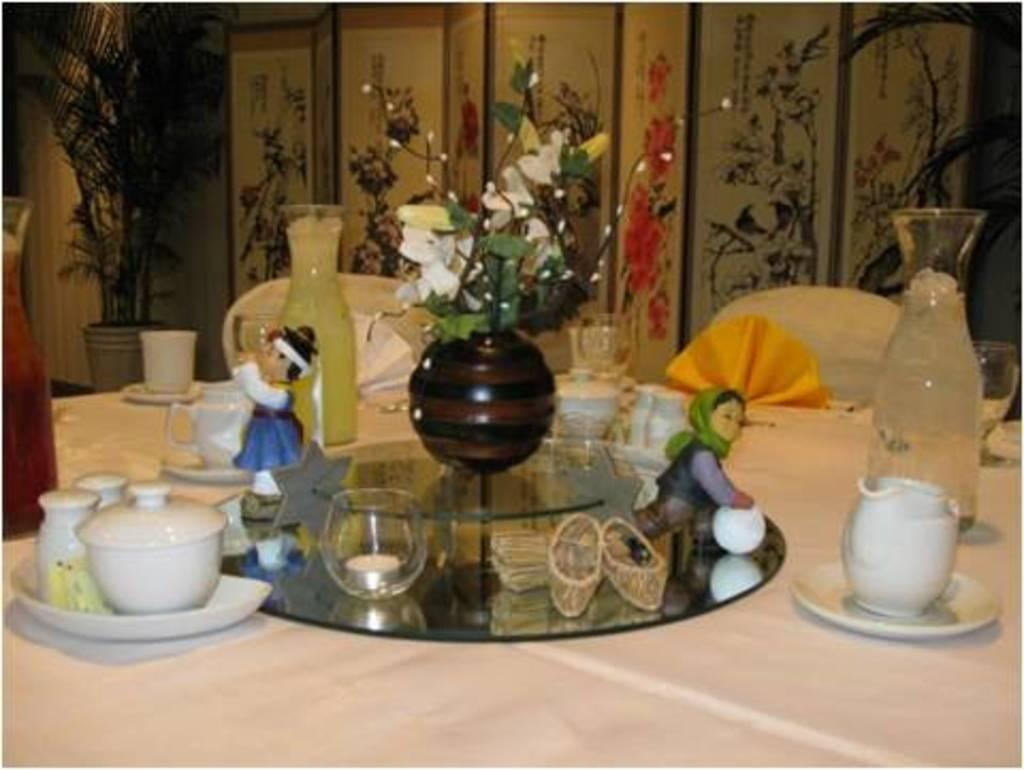What type of items can be seen on the table in the image? There are toys, cups, saucers, and flowers on the table in the image. What other objects are present on the table? There are other objects on the table, but their specific details are not mentioned in the facts. What can be seen in the background of the image? There is a plant pot and other objects in the background. What type of chalk is being used to draw on the table in the image? There is no chalk present in the image, and therefore no drawing activity can be observed. 